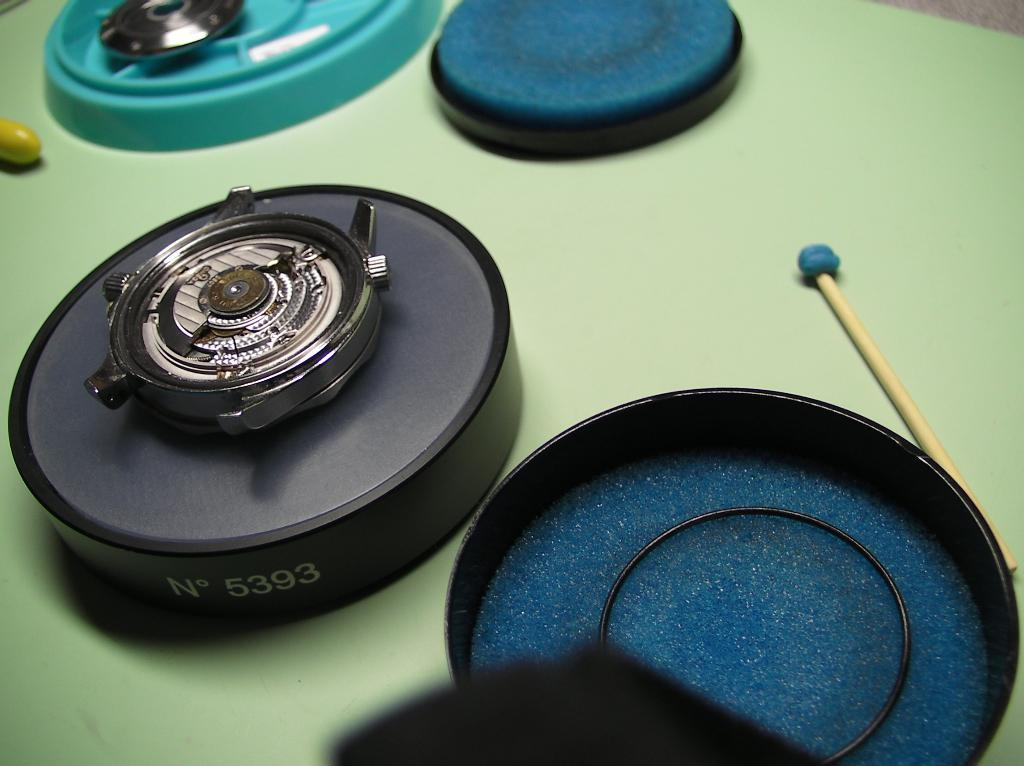What is the main subject of the image? There is a camera lens in the image. Are there any other objects visible in the image? Yes, there are other objects in the image. What color is the surface that is present in the image? The green color surface is present in the image. How many letters can be seen in the image? There is no mention of letters in the provided facts, so we cannot determine if any are present in the image. 